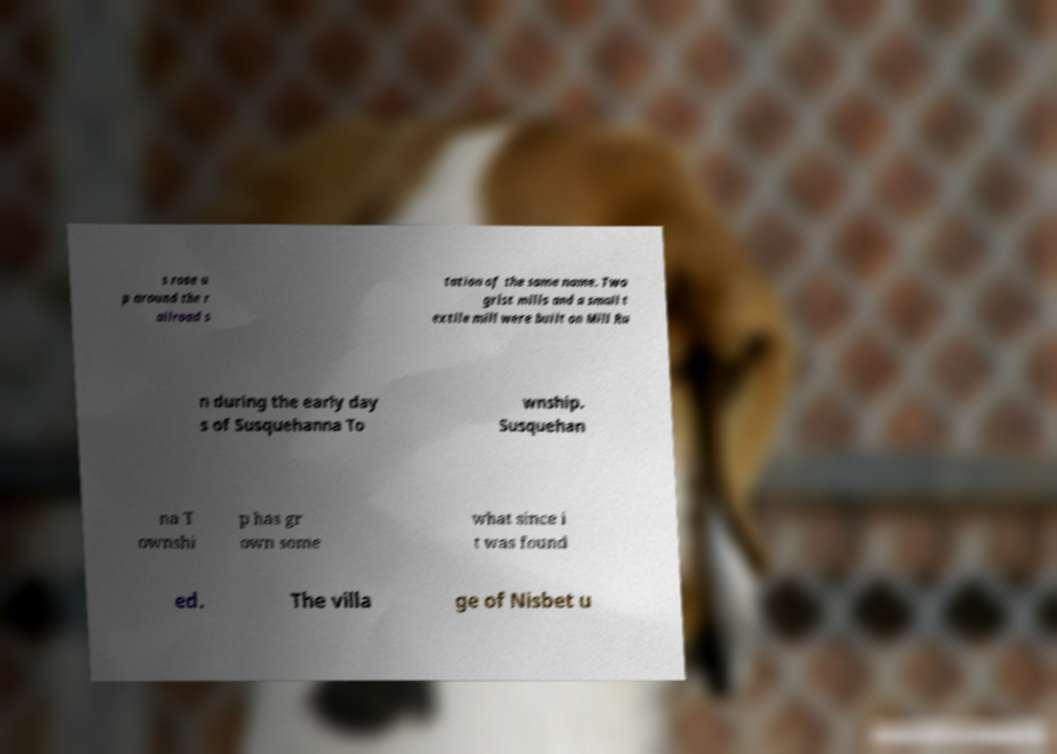For documentation purposes, I need the text within this image transcribed. Could you provide that? s rose u p around the r ailroad s tation of the same name. Two grist mills and a small t extile mill were built on Mill Ru n during the early day s of Susquehanna To wnship. Susquehan na T ownshi p has gr own some what since i t was found ed. The villa ge of Nisbet u 